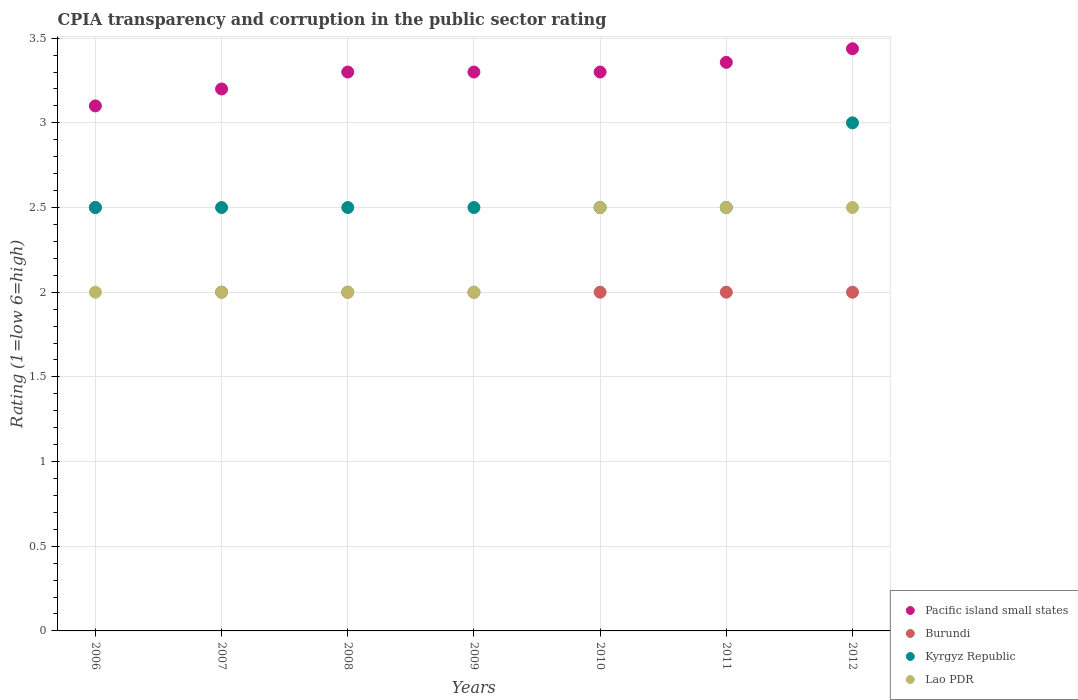Is the number of dotlines equal to the number of legend labels?
Make the answer very short. Yes. What is the CPIA rating in Burundi in 2012?
Make the answer very short. 2. In which year was the CPIA rating in Burundi minimum?
Give a very brief answer. 2007. What is the total CPIA rating in Pacific island small states in the graph?
Your answer should be compact. 22.99. What is the average CPIA rating in Kyrgyz Republic per year?
Make the answer very short. 2.57. In the year 2010, what is the difference between the CPIA rating in Pacific island small states and CPIA rating in Kyrgyz Republic?
Ensure brevity in your answer.  0.8. In how many years, is the CPIA rating in Pacific island small states greater than 0.8?
Your answer should be compact. 7. What is the ratio of the CPIA rating in Lao PDR in 2008 to that in 2009?
Offer a very short reply. 1. What is the difference between the highest and the second highest CPIA rating in Lao PDR?
Make the answer very short. 0. What is the difference between the highest and the lowest CPIA rating in Kyrgyz Republic?
Provide a succinct answer. 0.5. In how many years, is the CPIA rating in Burundi greater than the average CPIA rating in Burundi taken over all years?
Your response must be concise. 1. Is the sum of the CPIA rating in Pacific island small states in 2007 and 2012 greater than the maximum CPIA rating in Kyrgyz Republic across all years?
Your answer should be very brief. Yes. Is the CPIA rating in Pacific island small states strictly less than the CPIA rating in Kyrgyz Republic over the years?
Your response must be concise. No. How many dotlines are there?
Offer a very short reply. 4. How many years are there in the graph?
Your response must be concise. 7. Are the values on the major ticks of Y-axis written in scientific E-notation?
Your response must be concise. No. What is the title of the graph?
Provide a succinct answer. CPIA transparency and corruption in the public sector rating. What is the Rating (1=low 6=high) in Pacific island small states in 2006?
Make the answer very short. 3.1. What is the Rating (1=low 6=high) in Burundi in 2006?
Ensure brevity in your answer.  2.5. What is the Rating (1=low 6=high) in Burundi in 2007?
Keep it short and to the point. 2. What is the Rating (1=low 6=high) of Lao PDR in 2007?
Provide a succinct answer. 2. What is the Rating (1=low 6=high) of Pacific island small states in 2008?
Your answer should be very brief. 3.3. What is the Rating (1=low 6=high) in Burundi in 2008?
Make the answer very short. 2. What is the Rating (1=low 6=high) in Kyrgyz Republic in 2008?
Provide a succinct answer. 2.5. What is the Rating (1=low 6=high) of Pacific island small states in 2009?
Your answer should be compact. 3.3. What is the Rating (1=low 6=high) of Kyrgyz Republic in 2009?
Keep it short and to the point. 2.5. What is the Rating (1=low 6=high) in Lao PDR in 2009?
Provide a succinct answer. 2. What is the Rating (1=low 6=high) in Burundi in 2010?
Provide a succinct answer. 2. What is the Rating (1=low 6=high) of Kyrgyz Republic in 2010?
Offer a terse response. 2.5. What is the Rating (1=low 6=high) of Pacific island small states in 2011?
Keep it short and to the point. 3.36. What is the Rating (1=low 6=high) in Pacific island small states in 2012?
Provide a short and direct response. 3.44. What is the Rating (1=low 6=high) of Burundi in 2012?
Ensure brevity in your answer.  2. What is the Rating (1=low 6=high) in Kyrgyz Republic in 2012?
Your answer should be very brief. 3. What is the Rating (1=low 6=high) in Lao PDR in 2012?
Ensure brevity in your answer.  2.5. Across all years, what is the maximum Rating (1=low 6=high) in Pacific island small states?
Make the answer very short. 3.44. Across all years, what is the maximum Rating (1=low 6=high) in Kyrgyz Republic?
Keep it short and to the point. 3. Across all years, what is the minimum Rating (1=low 6=high) of Kyrgyz Republic?
Your response must be concise. 2.5. Across all years, what is the minimum Rating (1=low 6=high) of Lao PDR?
Offer a very short reply. 2. What is the total Rating (1=low 6=high) in Pacific island small states in the graph?
Your answer should be compact. 22.99. What is the total Rating (1=low 6=high) of Burundi in the graph?
Give a very brief answer. 14.5. What is the total Rating (1=low 6=high) in Lao PDR in the graph?
Your answer should be very brief. 15.5. What is the difference between the Rating (1=low 6=high) in Pacific island small states in 2006 and that in 2007?
Provide a short and direct response. -0.1. What is the difference between the Rating (1=low 6=high) of Burundi in 2006 and that in 2007?
Offer a terse response. 0.5. What is the difference between the Rating (1=low 6=high) of Pacific island small states in 2006 and that in 2008?
Ensure brevity in your answer.  -0.2. What is the difference between the Rating (1=low 6=high) in Burundi in 2006 and that in 2008?
Your answer should be very brief. 0.5. What is the difference between the Rating (1=low 6=high) of Lao PDR in 2006 and that in 2008?
Provide a succinct answer. 0. What is the difference between the Rating (1=low 6=high) of Pacific island small states in 2006 and that in 2009?
Your answer should be very brief. -0.2. What is the difference between the Rating (1=low 6=high) of Burundi in 2006 and that in 2009?
Offer a very short reply. 0.5. What is the difference between the Rating (1=low 6=high) in Kyrgyz Republic in 2006 and that in 2009?
Give a very brief answer. 0. What is the difference between the Rating (1=low 6=high) of Pacific island small states in 2006 and that in 2010?
Keep it short and to the point. -0.2. What is the difference between the Rating (1=low 6=high) of Burundi in 2006 and that in 2010?
Your answer should be very brief. 0.5. What is the difference between the Rating (1=low 6=high) of Kyrgyz Republic in 2006 and that in 2010?
Your answer should be compact. 0. What is the difference between the Rating (1=low 6=high) of Lao PDR in 2006 and that in 2010?
Make the answer very short. -0.5. What is the difference between the Rating (1=low 6=high) in Pacific island small states in 2006 and that in 2011?
Provide a succinct answer. -0.26. What is the difference between the Rating (1=low 6=high) in Burundi in 2006 and that in 2011?
Your response must be concise. 0.5. What is the difference between the Rating (1=low 6=high) of Kyrgyz Republic in 2006 and that in 2011?
Give a very brief answer. 0. What is the difference between the Rating (1=low 6=high) of Pacific island small states in 2006 and that in 2012?
Keep it short and to the point. -0.34. What is the difference between the Rating (1=low 6=high) in Burundi in 2006 and that in 2012?
Your answer should be very brief. 0.5. What is the difference between the Rating (1=low 6=high) in Kyrgyz Republic in 2006 and that in 2012?
Give a very brief answer. -0.5. What is the difference between the Rating (1=low 6=high) of Lao PDR in 2006 and that in 2012?
Your answer should be very brief. -0.5. What is the difference between the Rating (1=low 6=high) in Pacific island small states in 2007 and that in 2008?
Your answer should be very brief. -0.1. What is the difference between the Rating (1=low 6=high) of Burundi in 2007 and that in 2008?
Your response must be concise. 0. What is the difference between the Rating (1=low 6=high) of Lao PDR in 2007 and that in 2008?
Provide a short and direct response. 0. What is the difference between the Rating (1=low 6=high) in Burundi in 2007 and that in 2009?
Offer a very short reply. 0. What is the difference between the Rating (1=low 6=high) of Lao PDR in 2007 and that in 2009?
Keep it short and to the point. 0. What is the difference between the Rating (1=low 6=high) of Burundi in 2007 and that in 2010?
Offer a terse response. 0. What is the difference between the Rating (1=low 6=high) in Lao PDR in 2007 and that in 2010?
Offer a terse response. -0.5. What is the difference between the Rating (1=low 6=high) in Pacific island small states in 2007 and that in 2011?
Your answer should be very brief. -0.16. What is the difference between the Rating (1=low 6=high) in Kyrgyz Republic in 2007 and that in 2011?
Keep it short and to the point. 0. What is the difference between the Rating (1=low 6=high) in Lao PDR in 2007 and that in 2011?
Give a very brief answer. -0.5. What is the difference between the Rating (1=low 6=high) in Pacific island small states in 2007 and that in 2012?
Ensure brevity in your answer.  -0.24. What is the difference between the Rating (1=low 6=high) of Burundi in 2007 and that in 2012?
Offer a terse response. 0. What is the difference between the Rating (1=low 6=high) in Kyrgyz Republic in 2007 and that in 2012?
Ensure brevity in your answer.  -0.5. What is the difference between the Rating (1=low 6=high) of Pacific island small states in 2008 and that in 2009?
Offer a very short reply. 0. What is the difference between the Rating (1=low 6=high) of Burundi in 2008 and that in 2009?
Make the answer very short. 0. What is the difference between the Rating (1=low 6=high) in Kyrgyz Republic in 2008 and that in 2009?
Give a very brief answer. 0. What is the difference between the Rating (1=low 6=high) of Burundi in 2008 and that in 2010?
Your answer should be compact. 0. What is the difference between the Rating (1=low 6=high) in Kyrgyz Republic in 2008 and that in 2010?
Provide a succinct answer. 0. What is the difference between the Rating (1=low 6=high) in Pacific island small states in 2008 and that in 2011?
Give a very brief answer. -0.06. What is the difference between the Rating (1=low 6=high) in Burundi in 2008 and that in 2011?
Your answer should be very brief. 0. What is the difference between the Rating (1=low 6=high) in Pacific island small states in 2008 and that in 2012?
Your answer should be very brief. -0.14. What is the difference between the Rating (1=low 6=high) of Burundi in 2008 and that in 2012?
Offer a terse response. 0. What is the difference between the Rating (1=low 6=high) of Lao PDR in 2008 and that in 2012?
Keep it short and to the point. -0.5. What is the difference between the Rating (1=low 6=high) of Pacific island small states in 2009 and that in 2011?
Ensure brevity in your answer.  -0.06. What is the difference between the Rating (1=low 6=high) in Kyrgyz Republic in 2009 and that in 2011?
Give a very brief answer. 0. What is the difference between the Rating (1=low 6=high) in Lao PDR in 2009 and that in 2011?
Keep it short and to the point. -0.5. What is the difference between the Rating (1=low 6=high) in Pacific island small states in 2009 and that in 2012?
Your response must be concise. -0.14. What is the difference between the Rating (1=low 6=high) of Pacific island small states in 2010 and that in 2011?
Your answer should be compact. -0.06. What is the difference between the Rating (1=low 6=high) in Kyrgyz Republic in 2010 and that in 2011?
Your answer should be very brief. 0. What is the difference between the Rating (1=low 6=high) in Lao PDR in 2010 and that in 2011?
Give a very brief answer. 0. What is the difference between the Rating (1=low 6=high) of Pacific island small states in 2010 and that in 2012?
Ensure brevity in your answer.  -0.14. What is the difference between the Rating (1=low 6=high) in Lao PDR in 2010 and that in 2012?
Offer a terse response. 0. What is the difference between the Rating (1=low 6=high) of Pacific island small states in 2011 and that in 2012?
Your answer should be compact. -0.08. What is the difference between the Rating (1=low 6=high) of Lao PDR in 2011 and that in 2012?
Ensure brevity in your answer.  0. What is the difference between the Rating (1=low 6=high) of Pacific island small states in 2006 and the Rating (1=low 6=high) of Lao PDR in 2007?
Offer a very short reply. 1.1. What is the difference between the Rating (1=low 6=high) of Kyrgyz Republic in 2006 and the Rating (1=low 6=high) of Lao PDR in 2007?
Your answer should be compact. 0.5. What is the difference between the Rating (1=low 6=high) in Pacific island small states in 2006 and the Rating (1=low 6=high) in Kyrgyz Republic in 2008?
Provide a short and direct response. 0.6. What is the difference between the Rating (1=low 6=high) in Burundi in 2006 and the Rating (1=low 6=high) in Lao PDR in 2008?
Make the answer very short. 0.5. What is the difference between the Rating (1=low 6=high) of Kyrgyz Republic in 2006 and the Rating (1=low 6=high) of Lao PDR in 2008?
Offer a terse response. 0.5. What is the difference between the Rating (1=low 6=high) of Pacific island small states in 2006 and the Rating (1=low 6=high) of Burundi in 2009?
Give a very brief answer. 1.1. What is the difference between the Rating (1=low 6=high) in Burundi in 2006 and the Rating (1=low 6=high) in Kyrgyz Republic in 2009?
Offer a terse response. 0. What is the difference between the Rating (1=low 6=high) in Pacific island small states in 2006 and the Rating (1=low 6=high) in Burundi in 2010?
Give a very brief answer. 1.1. What is the difference between the Rating (1=low 6=high) in Pacific island small states in 2006 and the Rating (1=low 6=high) in Kyrgyz Republic in 2010?
Provide a succinct answer. 0.6. What is the difference between the Rating (1=low 6=high) of Pacific island small states in 2006 and the Rating (1=low 6=high) of Lao PDR in 2010?
Your response must be concise. 0.6. What is the difference between the Rating (1=low 6=high) in Burundi in 2006 and the Rating (1=low 6=high) in Kyrgyz Republic in 2010?
Your response must be concise. 0. What is the difference between the Rating (1=low 6=high) of Burundi in 2006 and the Rating (1=low 6=high) of Lao PDR in 2010?
Provide a short and direct response. 0. What is the difference between the Rating (1=low 6=high) in Pacific island small states in 2006 and the Rating (1=low 6=high) in Kyrgyz Republic in 2011?
Provide a succinct answer. 0.6. What is the difference between the Rating (1=low 6=high) in Pacific island small states in 2006 and the Rating (1=low 6=high) in Lao PDR in 2011?
Provide a succinct answer. 0.6. What is the difference between the Rating (1=low 6=high) in Burundi in 2006 and the Rating (1=low 6=high) in Kyrgyz Republic in 2011?
Ensure brevity in your answer.  0. What is the difference between the Rating (1=low 6=high) of Burundi in 2006 and the Rating (1=low 6=high) of Lao PDR in 2011?
Provide a succinct answer. 0. What is the difference between the Rating (1=low 6=high) in Kyrgyz Republic in 2006 and the Rating (1=low 6=high) in Lao PDR in 2011?
Offer a terse response. 0. What is the difference between the Rating (1=low 6=high) in Pacific island small states in 2006 and the Rating (1=low 6=high) in Burundi in 2012?
Your answer should be compact. 1.1. What is the difference between the Rating (1=low 6=high) in Pacific island small states in 2006 and the Rating (1=low 6=high) in Lao PDR in 2012?
Offer a very short reply. 0.6. What is the difference between the Rating (1=low 6=high) in Burundi in 2006 and the Rating (1=low 6=high) in Kyrgyz Republic in 2012?
Provide a succinct answer. -0.5. What is the difference between the Rating (1=low 6=high) in Kyrgyz Republic in 2006 and the Rating (1=low 6=high) in Lao PDR in 2012?
Provide a succinct answer. 0. What is the difference between the Rating (1=low 6=high) in Pacific island small states in 2007 and the Rating (1=low 6=high) in Burundi in 2008?
Provide a succinct answer. 1.2. What is the difference between the Rating (1=low 6=high) in Pacific island small states in 2007 and the Rating (1=low 6=high) in Lao PDR in 2008?
Your response must be concise. 1.2. What is the difference between the Rating (1=low 6=high) in Pacific island small states in 2007 and the Rating (1=low 6=high) in Burundi in 2010?
Ensure brevity in your answer.  1.2. What is the difference between the Rating (1=low 6=high) of Pacific island small states in 2007 and the Rating (1=low 6=high) of Lao PDR in 2010?
Provide a succinct answer. 0.7. What is the difference between the Rating (1=low 6=high) in Burundi in 2007 and the Rating (1=low 6=high) in Kyrgyz Republic in 2010?
Your answer should be compact. -0.5. What is the difference between the Rating (1=low 6=high) in Kyrgyz Republic in 2007 and the Rating (1=low 6=high) in Lao PDR in 2010?
Give a very brief answer. 0. What is the difference between the Rating (1=low 6=high) of Pacific island small states in 2007 and the Rating (1=low 6=high) of Kyrgyz Republic in 2011?
Give a very brief answer. 0.7. What is the difference between the Rating (1=low 6=high) of Burundi in 2007 and the Rating (1=low 6=high) of Kyrgyz Republic in 2011?
Offer a terse response. -0.5. What is the difference between the Rating (1=low 6=high) in Pacific island small states in 2007 and the Rating (1=low 6=high) in Lao PDR in 2012?
Keep it short and to the point. 0.7. What is the difference between the Rating (1=low 6=high) in Burundi in 2007 and the Rating (1=low 6=high) in Lao PDR in 2012?
Provide a succinct answer. -0.5. What is the difference between the Rating (1=low 6=high) of Pacific island small states in 2008 and the Rating (1=low 6=high) of Kyrgyz Republic in 2009?
Keep it short and to the point. 0.8. What is the difference between the Rating (1=low 6=high) of Kyrgyz Republic in 2008 and the Rating (1=low 6=high) of Lao PDR in 2009?
Give a very brief answer. 0.5. What is the difference between the Rating (1=low 6=high) in Pacific island small states in 2008 and the Rating (1=low 6=high) in Kyrgyz Republic in 2010?
Provide a succinct answer. 0.8. What is the difference between the Rating (1=low 6=high) of Pacific island small states in 2008 and the Rating (1=low 6=high) of Lao PDR in 2010?
Give a very brief answer. 0.8. What is the difference between the Rating (1=low 6=high) of Burundi in 2008 and the Rating (1=low 6=high) of Kyrgyz Republic in 2010?
Your answer should be compact. -0.5. What is the difference between the Rating (1=low 6=high) of Burundi in 2008 and the Rating (1=low 6=high) of Lao PDR in 2010?
Provide a succinct answer. -0.5. What is the difference between the Rating (1=low 6=high) of Kyrgyz Republic in 2008 and the Rating (1=low 6=high) of Lao PDR in 2010?
Give a very brief answer. 0. What is the difference between the Rating (1=low 6=high) in Pacific island small states in 2008 and the Rating (1=low 6=high) in Lao PDR in 2011?
Make the answer very short. 0.8. What is the difference between the Rating (1=low 6=high) of Burundi in 2008 and the Rating (1=low 6=high) of Lao PDR in 2011?
Give a very brief answer. -0.5. What is the difference between the Rating (1=low 6=high) of Kyrgyz Republic in 2008 and the Rating (1=low 6=high) of Lao PDR in 2011?
Give a very brief answer. 0. What is the difference between the Rating (1=low 6=high) in Pacific island small states in 2008 and the Rating (1=low 6=high) in Burundi in 2012?
Provide a short and direct response. 1.3. What is the difference between the Rating (1=low 6=high) of Pacific island small states in 2008 and the Rating (1=low 6=high) of Kyrgyz Republic in 2012?
Provide a succinct answer. 0.3. What is the difference between the Rating (1=low 6=high) in Pacific island small states in 2008 and the Rating (1=low 6=high) in Lao PDR in 2012?
Give a very brief answer. 0.8. What is the difference between the Rating (1=low 6=high) of Burundi in 2008 and the Rating (1=low 6=high) of Kyrgyz Republic in 2012?
Your answer should be very brief. -1. What is the difference between the Rating (1=low 6=high) in Burundi in 2008 and the Rating (1=low 6=high) in Lao PDR in 2012?
Your answer should be compact. -0.5. What is the difference between the Rating (1=low 6=high) in Kyrgyz Republic in 2008 and the Rating (1=low 6=high) in Lao PDR in 2012?
Provide a short and direct response. 0. What is the difference between the Rating (1=low 6=high) in Pacific island small states in 2009 and the Rating (1=low 6=high) in Lao PDR in 2010?
Your answer should be very brief. 0.8. What is the difference between the Rating (1=low 6=high) of Burundi in 2009 and the Rating (1=low 6=high) of Kyrgyz Republic in 2010?
Provide a short and direct response. -0.5. What is the difference between the Rating (1=low 6=high) in Kyrgyz Republic in 2009 and the Rating (1=low 6=high) in Lao PDR in 2010?
Provide a succinct answer. 0. What is the difference between the Rating (1=low 6=high) in Pacific island small states in 2009 and the Rating (1=low 6=high) in Burundi in 2011?
Offer a very short reply. 1.3. What is the difference between the Rating (1=low 6=high) of Pacific island small states in 2009 and the Rating (1=low 6=high) of Kyrgyz Republic in 2011?
Offer a terse response. 0.8. What is the difference between the Rating (1=low 6=high) in Burundi in 2009 and the Rating (1=low 6=high) in Kyrgyz Republic in 2011?
Your answer should be very brief. -0.5. What is the difference between the Rating (1=low 6=high) in Burundi in 2009 and the Rating (1=low 6=high) in Lao PDR in 2011?
Ensure brevity in your answer.  -0.5. What is the difference between the Rating (1=low 6=high) of Kyrgyz Republic in 2009 and the Rating (1=low 6=high) of Lao PDR in 2011?
Your answer should be very brief. 0. What is the difference between the Rating (1=low 6=high) of Pacific island small states in 2009 and the Rating (1=low 6=high) of Kyrgyz Republic in 2012?
Provide a succinct answer. 0.3. What is the difference between the Rating (1=low 6=high) of Burundi in 2009 and the Rating (1=low 6=high) of Lao PDR in 2012?
Make the answer very short. -0.5. What is the difference between the Rating (1=low 6=high) of Pacific island small states in 2010 and the Rating (1=low 6=high) of Burundi in 2011?
Offer a very short reply. 1.3. What is the difference between the Rating (1=low 6=high) of Burundi in 2010 and the Rating (1=low 6=high) of Lao PDR in 2011?
Provide a succinct answer. -0.5. What is the difference between the Rating (1=low 6=high) in Pacific island small states in 2010 and the Rating (1=low 6=high) in Burundi in 2012?
Your answer should be compact. 1.3. What is the difference between the Rating (1=low 6=high) of Pacific island small states in 2010 and the Rating (1=low 6=high) of Kyrgyz Republic in 2012?
Give a very brief answer. 0.3. What is the difference between the Rating (1=low 6=high) of Pacific island small states in 2010 and the Rating (1=low 6=high) of Lao PDR in 2012?
Provide a succinct answer. 0.8. What is the difference between the Rating (1=low 6=high) in Burundi in 2010 and the Rating (1=low 6=high) in Kyrgyz Republic in 2012?
Ensure brevity in your answer.  -1. What is the difference between the Rating (1=low 6=high) of Pacific island small states in 2011 and the Rating (1=low 6=high) of Burundi in 2012?
Provide a succinct answer. 1.36. What is the difference between the Rating (1=low 6=high) in Pacific island small states in 2011 and the Rating (1=low 6=high) in Kyrgyz Republic in 2012?
Your answer should be compact. 0.36. What is the difference between the Rating (1=low 6=high) in Burundi in 2011 and the Rating (1=low 6=high) in Lao PDR in 2012?
Provide a short and direct response. -0.5. What is the difference between the Rating (1=low 6=high) in Kyrgyz Republic in 2011 and the Rating (1=low 6=high) in Lao PDR in 2012?
Keep it short and to the point. 0. What is the average Rating (1=low 6=high) of Pacific island small states per year?
Your response must be concise. 3.28. What is the average Rating (1=low 6=high) in Burundi per year?
Your answer should be compact. 2.07. What is the average Rating (1=low 6=high) in Kyrgyz Republic per year?
Make the answer very short. 2.57. What is the average Rating (1=low 6=high) of Lao PDR per year?
Keep it short and to the point. 2.21. In the year 2006, what is the difference between the Rating (1=low 6=high) in Pacific island small states and Rating (1=low 6=high) in Burundi?
Keep it short and to the point. 0.6. In the year 2006, what is the difference between the Rating (1=low 6=high) in Pacific island small states and Rating (1=low 6=high) in Kyrgyz Republic?
Your answer should be very brief. 0.6. In the year 2006, what is the difference between the Rating (1=low 6=high) in Burundi and Rating (1=low 6=high) in Kyrgyz Republic?
Make the answer very short. 0. In the year 2006, what is the difference between the Rating (1=low 6=high) of Burundi and Rating (1=low 6=high) of Lao PDR?
Ensure brevity in your answer.  0.5. In the year 2006, what is the difference between the Rating (1=low 6=high) of Kyrgyz Republic and Rating (1=low 6=high) of Lao PDR?
Your answer should be compact. 0.5. In the year 2007, what is the difference between the Rating (1=low 6=high) in Pacific island small states and Rating (1=low 6=high) in Burundi?
Give a very brief answer. 1.2. In the year 2007, what is the difference between the Rating (1=low 6=high) in Pacific island small states and Rating (1=low 6=high) in Kyrgyz Republic?
Your response must be concise. 0.7. In the year 2007, what is the difference between the Rating (1=low 6=high) of Pacific island small states and Rating (1=low 6=high) of Lao PDR?
Offer a very short reply. 1.2. In the year 2007, what is the difference between the Rating (1=low 6=high) of Burundi and Rating (1=low 6=high) of Kyrgyz Republic?
Give a very brief answer. -0.5. In the year 2007, what is the difference between the Rating (1=low 6=high) in Burundi and Rating (1=low 6=high) in Lao PDR?
Give a very brief answer. 0. In the year 2008, what is the difference between the Rating (1=low 6=high) in Pacific island small states and Rating (1=low 6=high) in Lao PDR?
Give a very brief answer. 1.3. In the year 2008, what is the difference between the Rating (1=low 6=high) of Burundi and Rating (1=low 6=high) of Lao PDR?
Your answer should be compact. 0. In the year 2009, what is the difference between the Rating (1=low 6=high) in Pacific island small states and Rating (1=low 6=high) in Kyrgyz Republic?
Provide a short and direct response. 0.8. In the year 2009, what is the difference between the Rating (1=low 6=high) of Pacific island small states and Rating (1=low 6=high) of Lao PDR?
Ensure brevity in your answer.  1.3. In the year 2009, what is the difference between the Rating (1=low 6=high) in Burundi and Rating (1=low 6=high) in Kyrgyz Republic?
Offer a terse response. -0.5. In the year 2010, what is the difference between the Rating (1=low 6=high) in Pacific island small states and Rating (1=low 6=high) in Burundi?
Your response must be concise. 1.3. In the year 2010, what is the difference between the Rating (1=low 6=high) of Pacific island small states and Rating (1=low 6=high) of Lao PDR?
Keep it short and to the point. 0.8. In the year 2010, what is the difference between the Rating (1=low 6=high) of Burundi and Rating (1=low 6=high) of Kyrgyz Republic?
Provide a succinct answer. -0.5. In the year 2010, what is the difference between the Rating (1=low 6=high) in Burundi and Rating (1=low 6=high) in Lao PDR?
Keep it short and to the point. -0.5. In the year 2010, what is the difference between the Rating (1=low 6=high) of Kyrgyz Republic and Rating (1=low 6=high) of Lao PDR?
Provide a succinct answer. 0. In the year 2011, what is the difference between the Rating (1=low 6=high) in Pacific island small states and Rating (1=low 6=high) in Burundi?
Provide a succinct answer. 1.36. In the year 2011, what is the difference between the Rating (1=low 6=high) of Pacific island small states and Rating (1=low 6=high) of Kyrgyz Republic?
Give a very brief answer. 0.86. In the year 2011, what is the difference between the Rating (1=low 6=high) in Burundi and Rating (1=low 6=high) in Kyrgyz Republic?
Provide a short and direct response. -0.5. In the year 2011, what is the difference between the Rating (1=low 6=high) of Kyrgyz Republic and Rating (1=low 6=high) of Lao PDR?
Your response must be concise. 0. In the year 2012, what is the difference between the Rating (1=low 6=high) of Pacific island small states and Rating (1=low 6=high) of Burundi?
Make the answer very short. 1.44. In the year 2012, what is the difference between the Rating (1=low 6=high) of Pacific island small states and Rating (1=low 6=high) of Kyrgyz Republic?
Ensure brevity in your answer.  0.44. In the year 2012, what is the difference between the Rating (1=low 6=high) in Pacific island small states and Rating (1=low 6=high) in Lao PDR?
Your answer should be compact. 0.94. In the year 2012, what is the difference between the Rating (1=low 6=high) of Burundi and Rating (1=low 6=high) of Kyrgyz Republic?
Give a very brief answer. -1. In the year 2012, what is the difference between the Rating (1=low 6=high) of Burundi and Rating (1=low 6=high) of Lao PDR?
Give a very brief answer. -0.5. In the year 2012, what is the difference between the Rating (1=low 6=high) in Kyrgyz Republic and Rating (1=low 6=high) in Lao PDR?
Provide a short and direct response. 0.5. What is the ratio of the Rating (1=low 6=high) of Pacific island small states in 2006 to that in 2007?
Your response must be concise. 0.97. What is the ratio of the Rating (1=low 6=high) in Burundi in 2006 to that in 2007?
Your answer should be compact. 1.25. What is the ratio of the Rating (1=low 6=high) in Pacific island small states in 2006 to that in 2008?
Make the answer very short. 0.94. What is the ratio of the Rating (1=low 6=high) of Kyrgyz Republic in 2006 to that in 2008?
Give a very brief answer. 1. What is the ratio of the Rating (1=low 6=high) in Lao PDR in 2006 to that in 2008?
Make the answer very short. 1. What is the ratio of the Rating (1=low 6=high) of Pacific island small states in 2006 to that in 2009?
Offer a very short reply. 0.94. What is the ratio of the Rating (1=low 6=high) in Lao PDR in 2006 to that in 2009?
Give a very brief answer. 1. What is the ratio of the Rating (1=low 6=high) in Pacific island small states in 2006 to that in 2010?
Make the answer very short. 0.94. What is the ratio of the Rating (1=low 6=high) in Burundi in 2006 to that in 2010?
Your answer should be compact. 1.25. What is the ratio of the Rating (1=low 6=high) of Lao PDR in 2006 to that in 2010?
Ensure brevity in your answer.  0.8. What is the ratio of the Rating (1=low 6=high) in Pacific island small states in 2006 to that in 2011?
Offer a very short reply. 0.92. What is the ratio of the Rating (1=low 6=high) in Lao PDR in 2006 to that in 2011?
Make the answer very short. 0.8. What is the ratio of the Rating (1=low 6=high) in Pacific island small states in 2006 to that in 2012?
Give a very brief answer. 0.9. What is the ratio of the Rating (1=low 6=high) in Burundi in 2006 to that in 2012?
Make the answer very short. 1.25. What is the ratio of the Rating (1=low 6=high) of Pacific island small states in 2007 to that in 2008?
Offer a terse response. 0.97. What is the ratio of the Rating (1=low 6=high) in Burundi in 2007 to that in 2008?
Provide a succinct answer. 1. What is the ratio of the Rating (1=low 6=high) of Pacific island small states in 2007 to that in 2009?
Keep it short and to the point. 0.97. What is the ratio of the Rating (1=low 6=high) of Burundi in 2007 to that in 2009?
Offer a terse response. 1. What is the ratio of the Rating (1=low 6=high) of Lao PDR in 2007 to that in 2009?
Provide a succinct answer. 1. What is the ratio of the Rating (1=low 6=high) of Pacific island small states in 2007 to that in 2010?
Offer a terse response. 0.97. What is the ratio of the Rating (1=low 6=high) in Pacific island small states in 2007 to that in 2011?
Ensure brevity in your answer.  0.95. What is the ratio of the Rating (1=low 6=high) in Pacific island small states in 2007 to that in 2012?
Make the answer very short. 0.93. What is the ratio of the Rating (1=low 6=high) in Burundi in 2007 to that in 2012?
Give a very brief answer. 1. What is the ratio of the Rating (1=low 6=high) of Lao PDR in 2008 to that in 2009?
Your answer should be very brief. 1. What is the ratio of the Rating (1=low 6=high) in Pacific island small states in 2008 to that in 2010?
Offer a terse response. 1. What is the ratio of the Rating (1=low 6=high) in Burundi in 2008 to that in 2010?
Offer a very short reply. 1. What is the ratio of the Rating (1=low 6=high) of Pacific island small states in 2008 to that in 2011?
Offer a very short reply. 0.98. What is the ratio of the Rating (1=low 6=high) of Kyrgyz Republic in 2008 to that in 2011?
Keep it short and to the point. 1. What is the ratio of the Rating (1=low 6=high) in Lao PDR in 2008 to that in 2011?
Provide a short and direct response. 0.8. What is the ratio of the Rating (1=low 6=high) of Burundi in 2008 to that in 2012?
Your answer should be very brief. 1. What is the ratio of the Rating (1=low 6=high) of Lao PDR in 2008 to that in 2012?
Offer a terse response. 0.8. What is the ratio of the Rating (1=low 6=high) in Burundi in 2009 to that in 2010?
Give a very brief answer. 1. What is the ratio of the Rating (1=low 6=high) in Lao PDR in 2009 to that in 2010?
Your response must be concise. 0.8. What is the ratio of the Rating (1=low 6=high) in Burundi in 2009 to that in 2011?
Your response must be concise. 1. What is the ratio of the Rating (1=low 6=high) in Lao PDR in 2009 to that in 2011?
Provide a short and direct response. 0.8. What is the ratio of the Rating (1=low 6=high) in Lao PDR in 2009 to that in 2012?
Your answer should be very brief. 0.8. What is the ratio of the Rating (1=low 6=high) of Pacific island small states in 2010 to that in 2011?
Your response must be concise. 0.98. What is the ratio of the Rating (1=low 6=high) in Burundi in 2010 to that in 2011?
Ensure brevity in your answer.  1. What is the ratio of the Rating (1=low 6=high) of Kyrgyz Republic in 2010 to that in 2011?
Ensure brevity in your answer.  1. What is the ratio of the Rating (1=low 6=high) of Lao PDR in 2010 to that in 2011?
Keep it short and to the point. 1. What is the ratio of the Rating (1=low 6=high) of Kyrgyz Republic in 2010 to that in 2012?
Offer a terse response. 0.83. What is the ratio of the Rating (1=low 6=high) in Lao PDR in 2010 to that in 2012?
Your answer should be very brief. 1. What is the ratio of the Rating (1=low 6=high) of Pacific island small states in 2011 to that in 2012?
Ensure brevity in your answer.  0.98. What is the ratio of the Rating (1=low 6=high) of Burundi in 2011 to that in 2012?
Make the answer very short. 1. What is the ratio of the Rating (1=low 6=high) in Kyrgyz Republic in 2011 to that in 2012?
Provide a succinct answer. 0.83. What is the difference between the highest and the second highest Rating (1=low 6=high) in Pacific island small states?
Ensure brevity in your answer.  0.08. What is the difference between the highest and the lowest Rating (1=low 6=high) of Pacific island small states?
Your response must be concise. 0.34. What is the difference between the highest and the lowest Rating (1=low 6=high) of Kyrgyz Republic?
Provide a succinct answer. 0.5. What is the difference between the highest and the lowest Rating (1=low 6=high) in Lao PDR?
Keep it short and to the point. 0.5. 